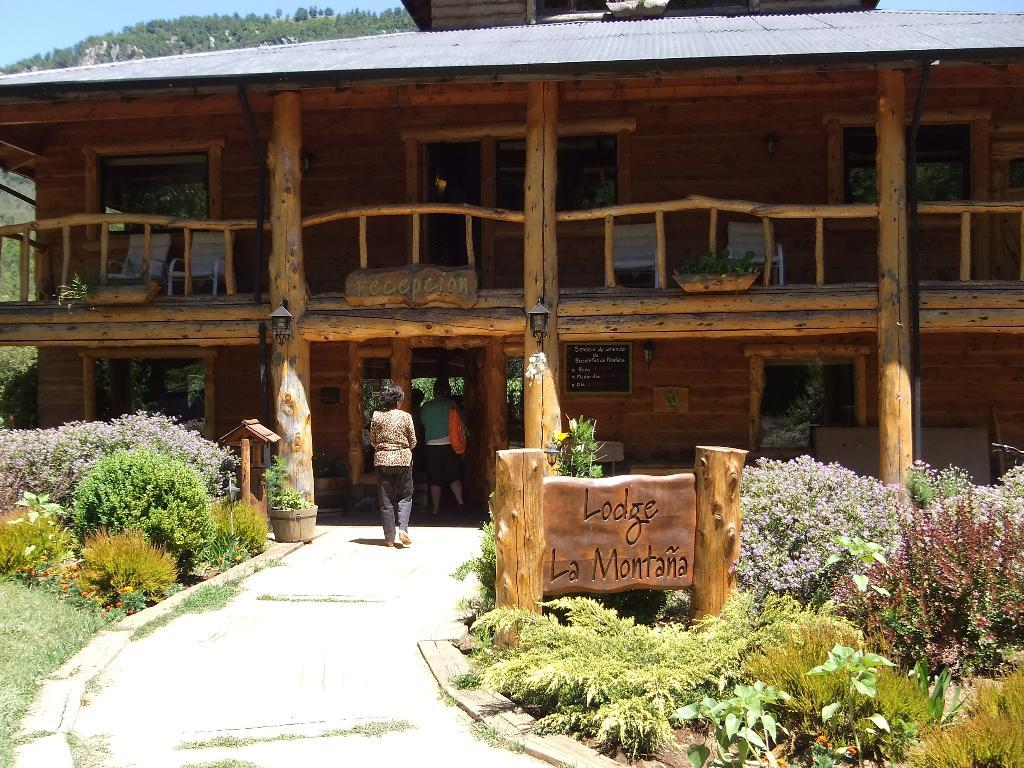<image>
Offer a succinct explanation of the picture presented. A wood two story building with a sign out front that says Lodge La Montana. 